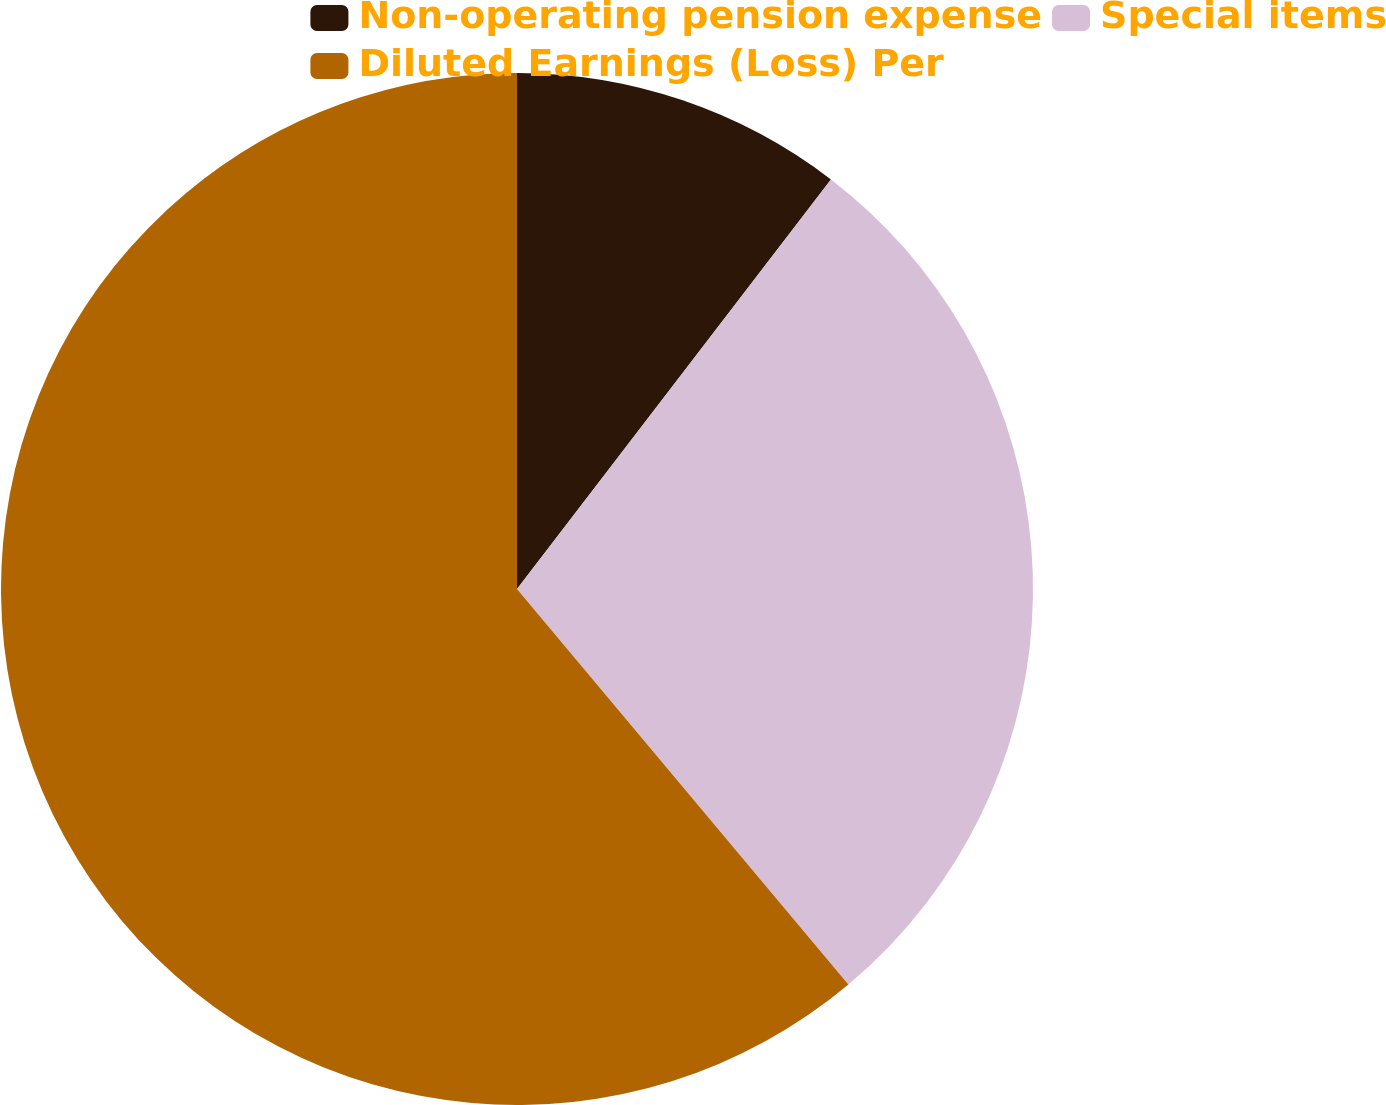Convert chart to OTSL. <chart><loc_0><loc_0><loc_500><loc_500><pie_chart><fcel>Non-operating pension expense<fcel>Special items<fcel>Diluted Earnings (Loss) Per<nl><fcel>10.41%<fcel>28.49%<fcel>61.1%<nl></chart> 